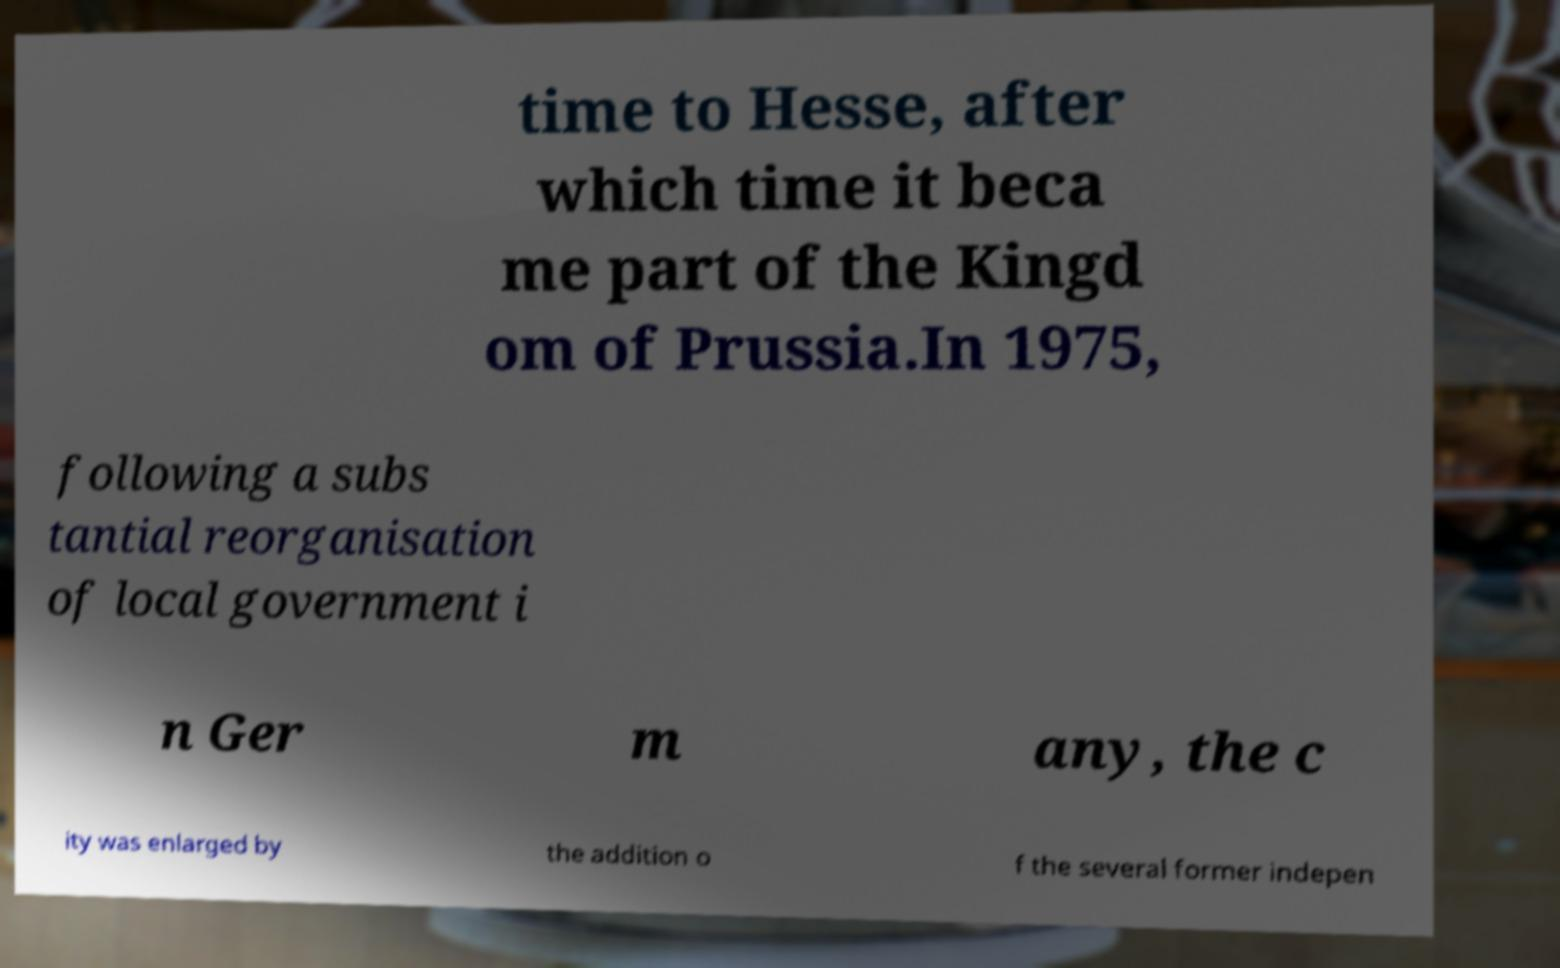What messages or text are displayed in this image? I need them in a readable, typed format. time to Hesse, after which time it beca me part of the Kingd om of Prussia.In 1975, following a subs tantial reorganisation of local government i n Ger m any, the c ity was enlarged by the addition o f the several former indepen 